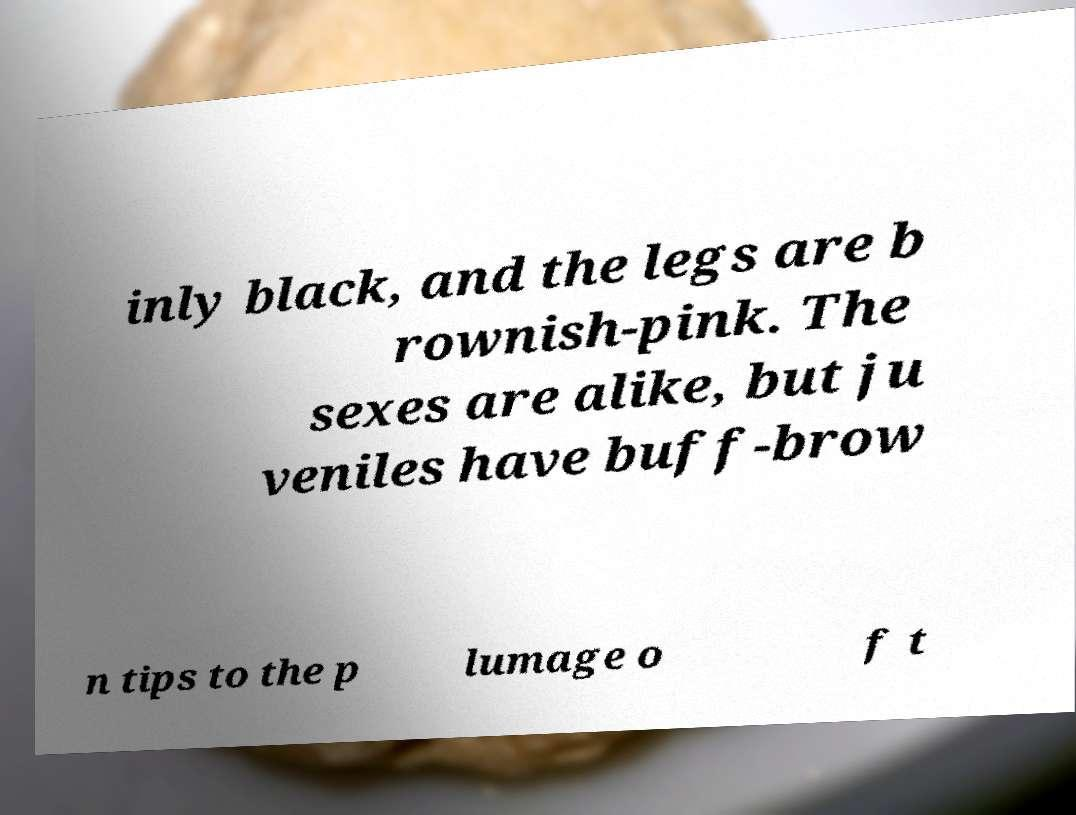For documentation purposes, I need the text within this image transcribed. Could you provide that? inly black, and the legs are b rownish-pink. The sexes are alike, but ju veniles have buff-brow n tips to the p lumage o f t 